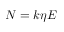Convert formula to latex. <formula><loc_0><loc_0><loc_500><loc_500>N = k \eta E</formula> 